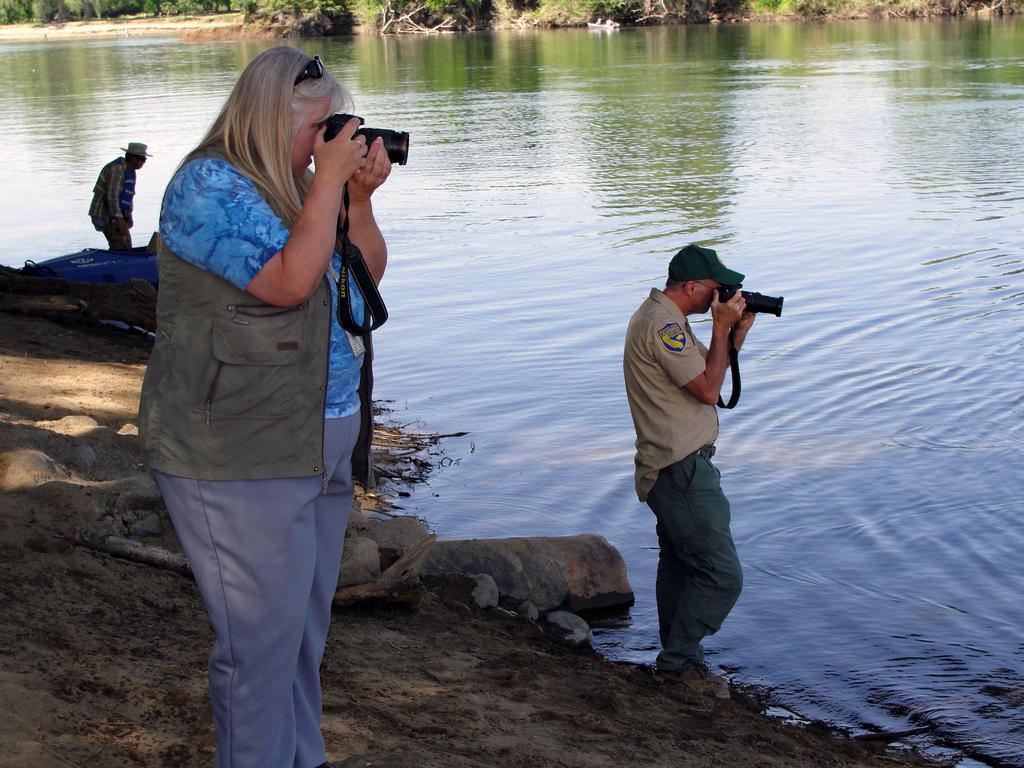How would you summarize this image in a sentence or two? In this image in the front there is a woman standing and holding a camera and clicking a photo. In the center there is a man standing and clicking a photo with a camera which is black in colour and on the left side there is a man standing and wearing a hat which is white in colour and in the background there is water and there are trees. 